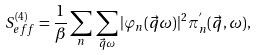Convert formula to latex. <formula><loc_0><loc_0><loc_500><loc_500>S _ { e f f } ^ { ( 4 ) } = \frac { 1 } { \beta } \sum _ { n } \, \sum _ { \vec { q } \omega } | \varphi _ { n } ( \vec { q } \omega ) | ^ { 2 } \pi _ { n } ^ { ^ { \prime } } ( \vec { q } , \omega ) ,</formula> 